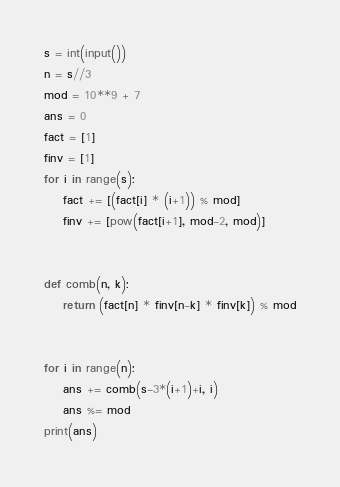<code> <loc_0><loc_0><loc_500><loc_500><_Python_>s = int(input())
n = s//3
mod = 10**9 + 7
ans = 0
fact = [1]
finv = [1]
for i in range(s):
    fact += [(fact[i] * (i+1)) % mod]
    finv += [pow(fact[i+1], mod-2, mod)]


def comb(n, k):
    return (fact[n] * finv[n-k] * finv[k]) % mod


for i in range(n):
    ans += comb(s-3*(i+1)+i, i)
    ans %= mod
print(ans)</code> 